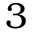Convert formula to latex. <formula><loc_0><loc_0><loc_500><loc_500>3</formula> 